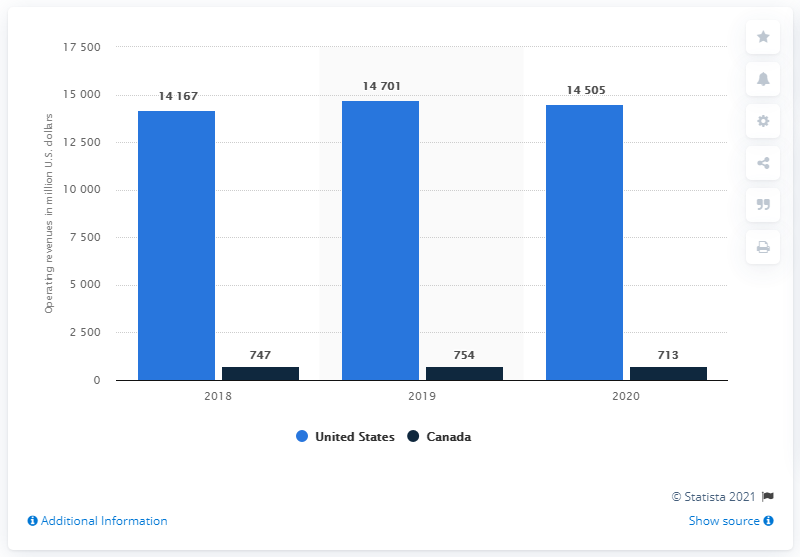Draw attention to some important aspects in this diagram. In the year ended December 31, 2020, the operating revenue of Waste Management Inc in the United States was approximately 14,505. 